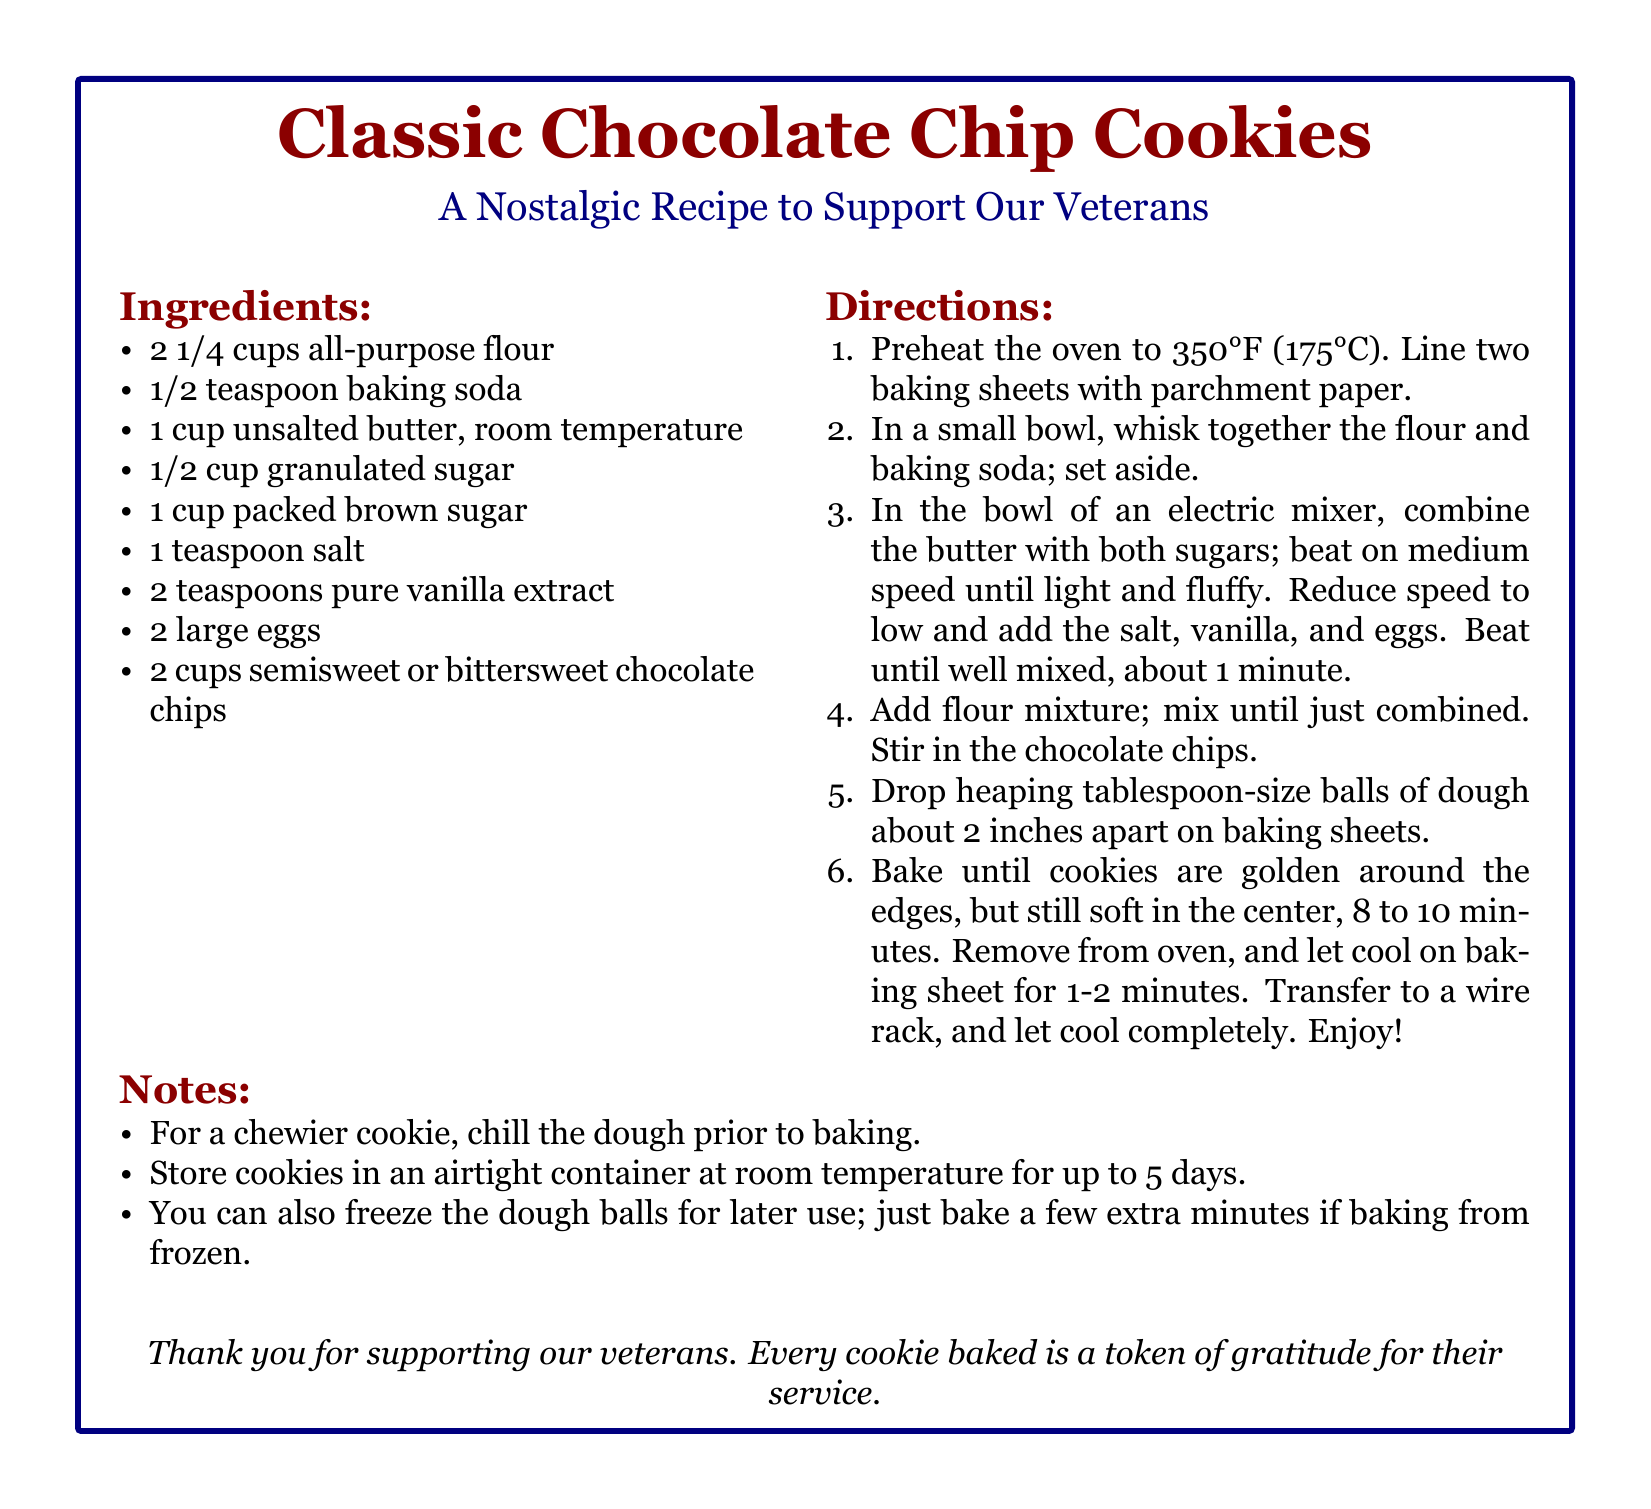What are the main ingredients? The main ingredients are listed in the ingredients section, which includes flour, butter, sugar, salt, eggs, and chocolate chips.
Answer: flour, butter, sugar, salt, eggs, chocolate chips What is the baking temperature? The baking temperature is specified in the directions and is necessary for properly baking the cookies.
Answer: 350°F How many cups of chocolate chips are needed? The amount of chocolate chips is detailed in the ingredients section, providing specific measurements.
Answer: 2 cups What is the purpose of the note about chilling the dough? The note explains that chilling the dough can affect the texture of the cookies, aimed at those interested in different cookie consistencies.
Answer: Chewier cookie How long should the cookies bake for? The baking time is indicated in the directions for the cookies to ensure they come out correctly.
Answer: 8 to 10 minutes What type of sugar is used in the recipe? The types of sugar used are specified in the ingredients list, contributing to the flavor and texture of the cookies.
Answer: Granulated and brown sugar What is a recommended storage method? The notes provide guidance on how to store the cookies after baking to maintain freshness.
Answer: Airtight container What is the emotional message at the end? The final message emphasizes gratitude and connects the recipe to the theme of supporting veterans.
Answer: Thank you for supporting our veterans 